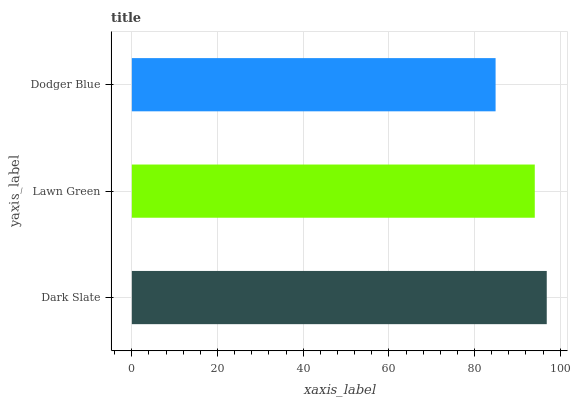Is Dodger Blue the minimum?
Answer yes or no. Yes. Is Dark Slate the maximum?
Answer yes or no. Yes. Is Lawn Green the minimum?
Answer yes or no. No. Is Lawn Green the maximum?
Answer yes or no. No. Is Dark Slate greater than Lawn Green?
Answer yes or no. Yes. Is Lawn Green less than Dark Slate?
Answer yes or no. Yes. Is Lawn Green greater than Dark Slate?
Answer yes or no. No. Is Dark Slate less than Lawn Green?
Answer yes or no. No. Is Lawn Green the high median?
Answer yes or no. Yes. Is Lawn Green the low median?
Answer yes or no. Yes. Is Dark Slate the high median?
Answer yes or no. No. Is Dodger Blue the low median?
Answer yes or no. No. 